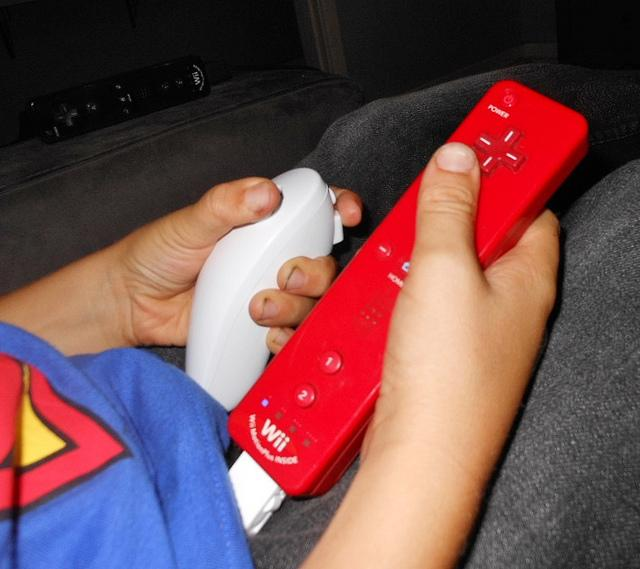How many players can play? one 